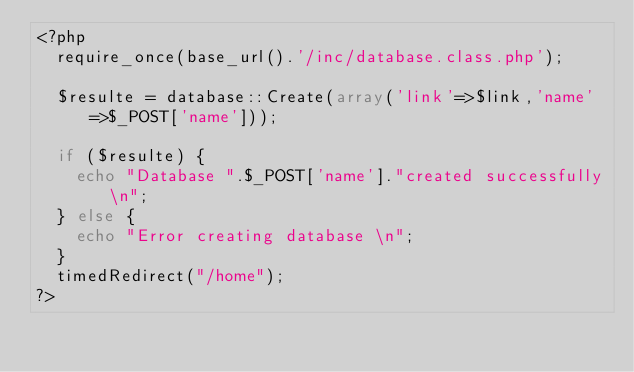Convert code to text. <code><loc_0><loc_0><loc_500><loc_500><_PHP_><?php
	require_once(base_url().'/inc/database.class.php');
	
	$resulte = database::Create(array('link'=>$link,'name'=>$_POST['name']));
	
	if ($resulte) {
		echo "Database ".$_POST['name']."created successfully\n";
	} else {
		echo "Error creating database \n";
	}
	timedRedirect("/home");
?></code> 